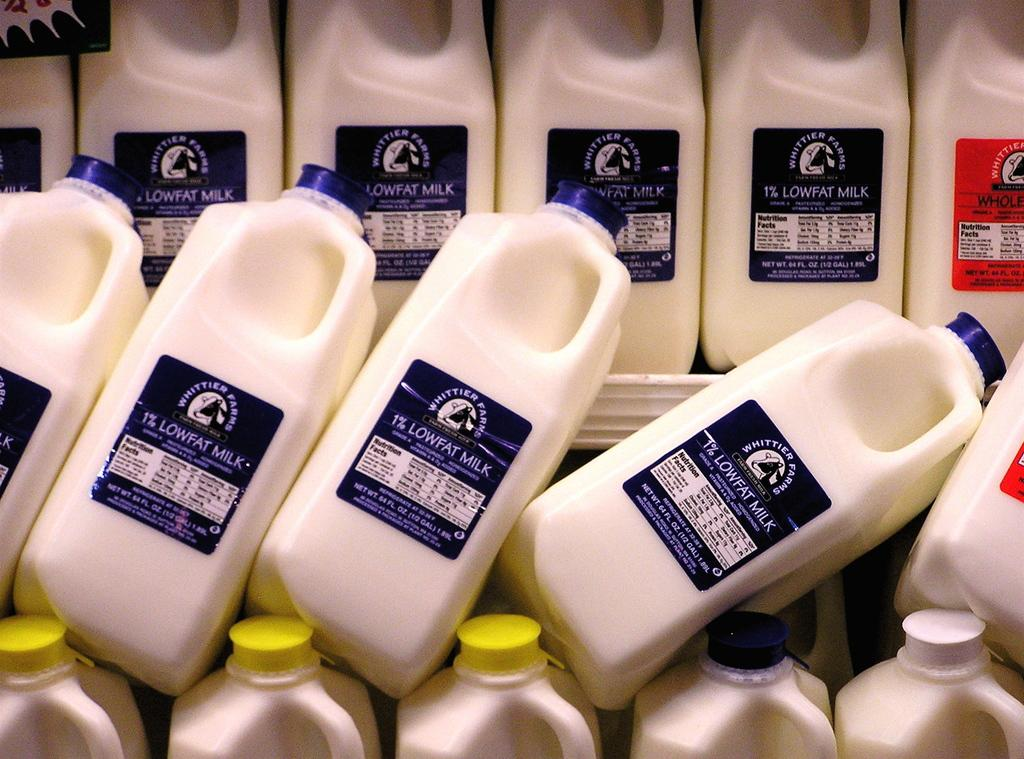<image>
Share a concise interpretation of the image provided. Lowfat milk cartons on top of one another that are 1%. 